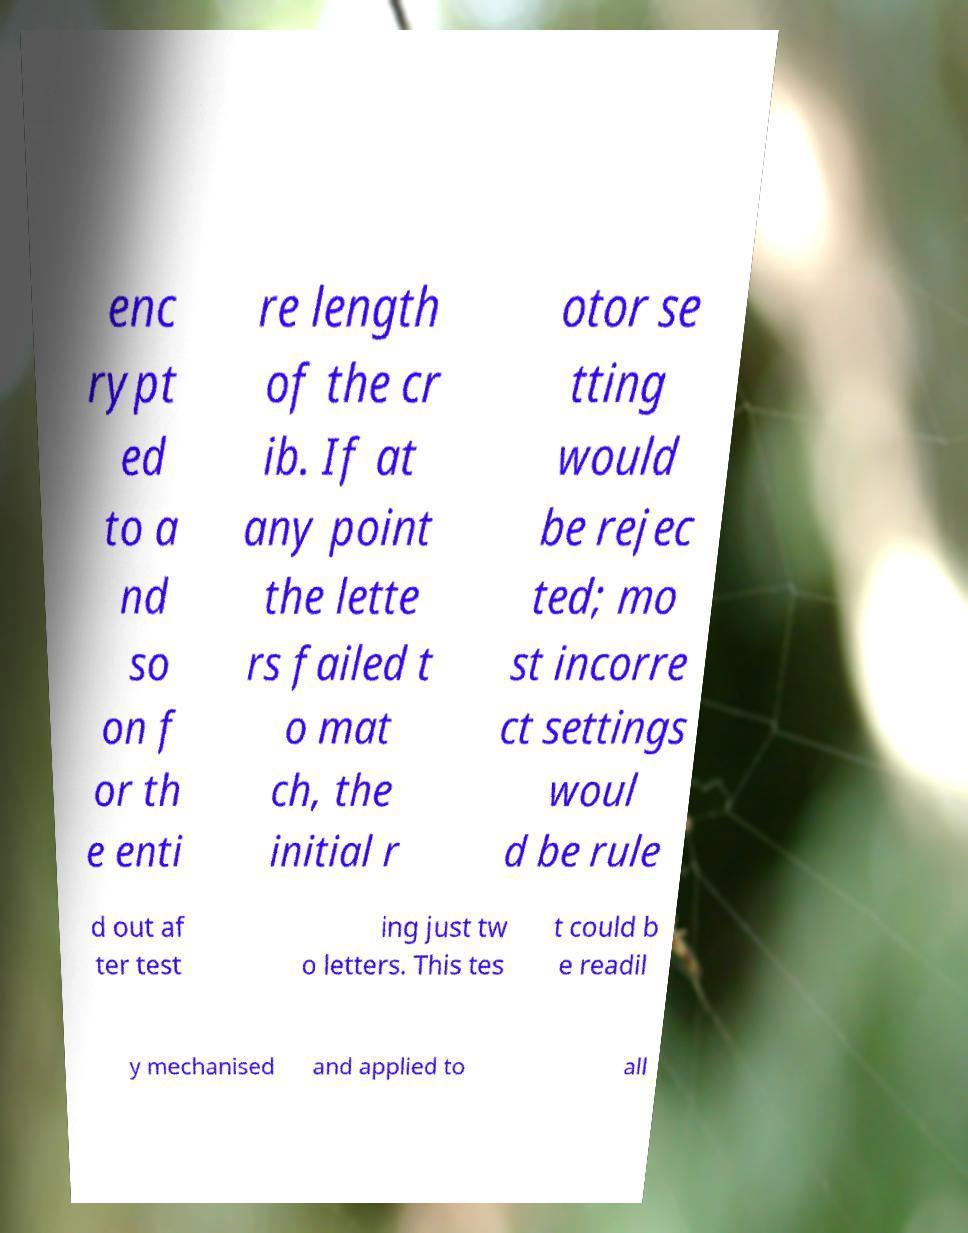Could you extract and type out the text from this image? enc rypt ed to a nd so on f or th e enti re length of the cr ib. If at any point the lette rs failed t o mat ch, the initial r otor se tting would be rejec ted; mo st incorre ct settings woul d be rule d out af ter test ing just tw o letters. This tes t could b e readil y mechanised and applied to all 